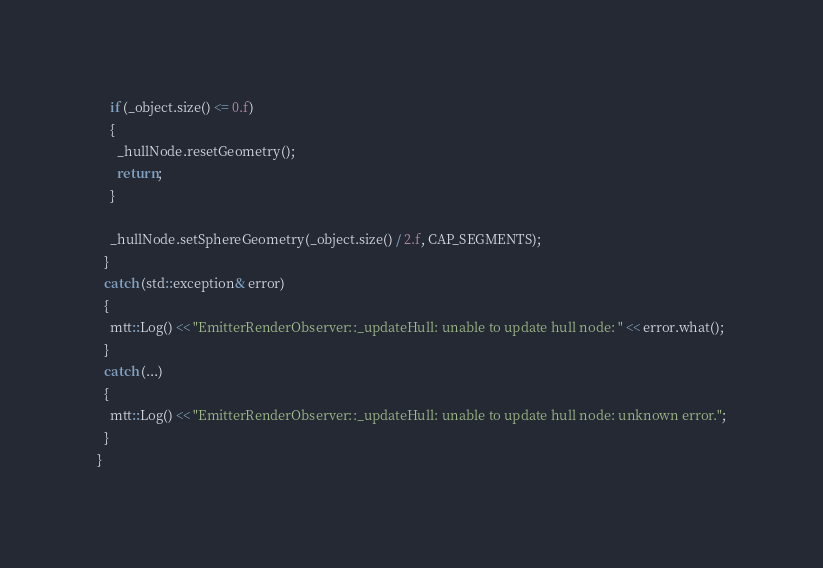Convert code to text. <code><loc_0><loc_0><loc_500><loc_500><_C++_>    if (_object.size() <= 0.f)
    {
      _hullNode.resetGeometry();
      return;
    }

    _hullNode.setSphereGeometry(_object.size() / 2.f, CAP_SEGMENTS);
  }
  catch (std::exception& error)
  {
    mtt::Log() << "EmitterRenderObserver::_updateHull: unable to update hull node: " << error.what();
  }
  catch (...)
  {
    mtt::Log() << "EmitterRenderObserver::_updateHull: unable to update hull node: unknown error.";
  }
}</code> 